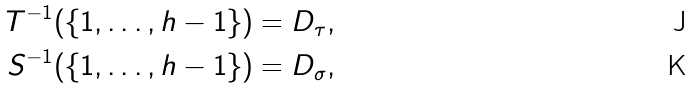<formula> <loc_0><loc_0><loc_500><loc_500>T ^ { - 1 } ( \{ 1 , \dots , h - 1 \} ) & = D _ { \tau } , \\ S ^ { - 1 } ( \{ 1 , \dots , h - 1 \} ) & = D _ { \sigma } ,</formula> 